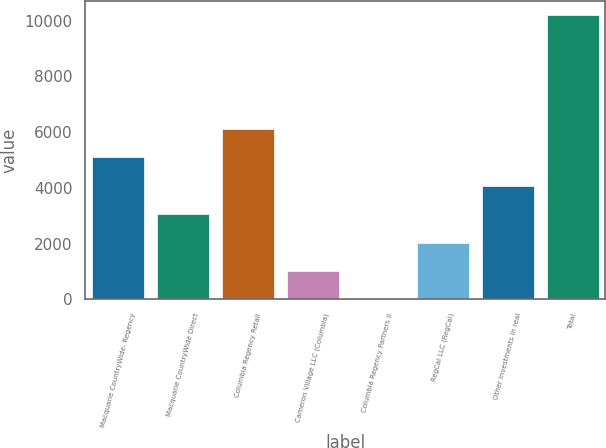Convert chart. <chart><loc_0><loc_0><loc_500><loc_500><bar_chart><fcel>Macquarie CountryWide- Regency<fcel>Macquarie CountryWide Direct<fcel>Columbia Regency Retail<fcel>Cameron Village LLC (Columbia)<fcel>Columbia Regency Partners II<fcel>RegCal LLC (RegCal)<fcel>Other investments in real<fcel>Total<nl><fcel>5097.5<fcel>3058.9<fcel>6116.8<fcel>1020.3<fcel>1<fcel>2039.6<fcel>4078.2<fcel>10194<nl></chart> 